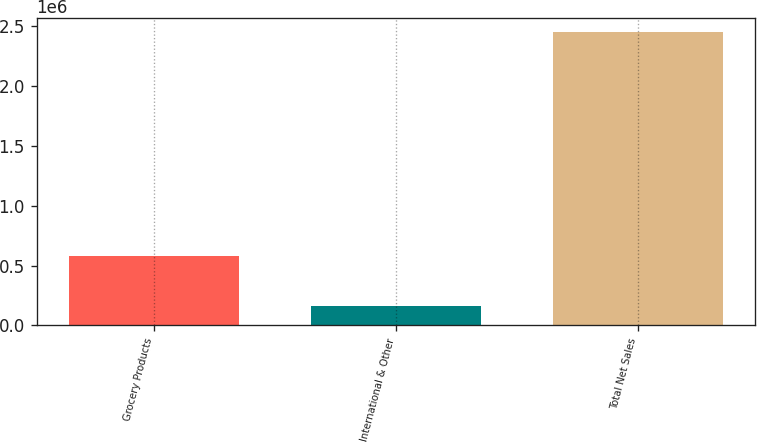Convert chart to OTSL. <chart><loc_0><loc_0><loc_500><loc_500><bar_chart><fcel>Grocery Products<fcel>International & Other<fcel>Total Net Sales<nl><fcel>576829<fcel>164158<fcel>2.45105e+06<nl></chart> 